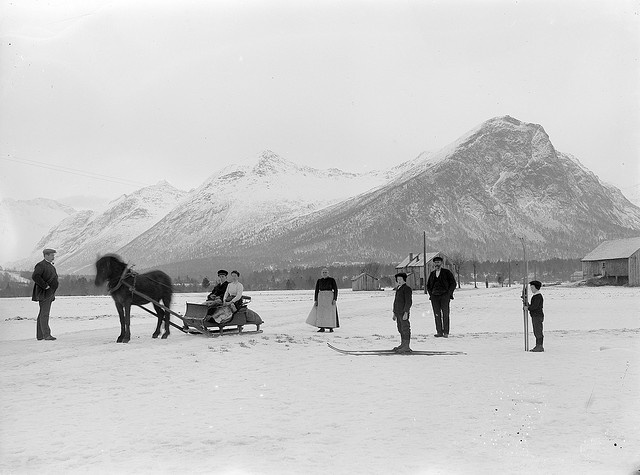Describe the objects in this image and their specific colors. I can see horse in white, black, gray, darkgray, and lightgray tones, people in white, black, gray, lightgray, and darkgray tones, people in white, black, gray, darkgray, and lightgray tones, people in white, gray, black, and lightgray tones, and people in white, black, gray, and lightgray tones in this image. 